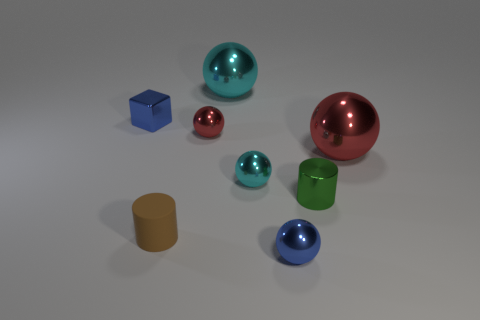There is a shiny object that is to the left of the small rubber cylinder; does it have the same color as the ball in front of the small brown object?
Give a very brief answer. Yes. Are there fewer small blue cubes in front of the tiny red sphere than tiny yellow things?
Give a very brief answer. No. How many things are gray rubber spheres or large spheres that are right of the small green object?
Your answer should be very brief. 1. What is the color of the other large sphere that is the same material as the large red sphere?
Offer a very short reply. Cyan. What number of things are big red things or large brown shiny cylinders?
Offer a very short reply. 1. What is the color of the rubber object that is the same size as the green metal thing?
Your answer should be very brief. Brown. What number of objects are either blue metallic objects left of the small brown rubber object or small brown cylinders?
Make the answer very short. 2. What number of other things are there of the same size as the blue ball?
Provide a succinct answer. 5. What is the size of the red ball to the right of the tiny blue ball?
Offer a terse response. Large. What is the shape of the green thing that is made of the same material as the tiny blue sphere?
Your response must be concise. Cylinder. 